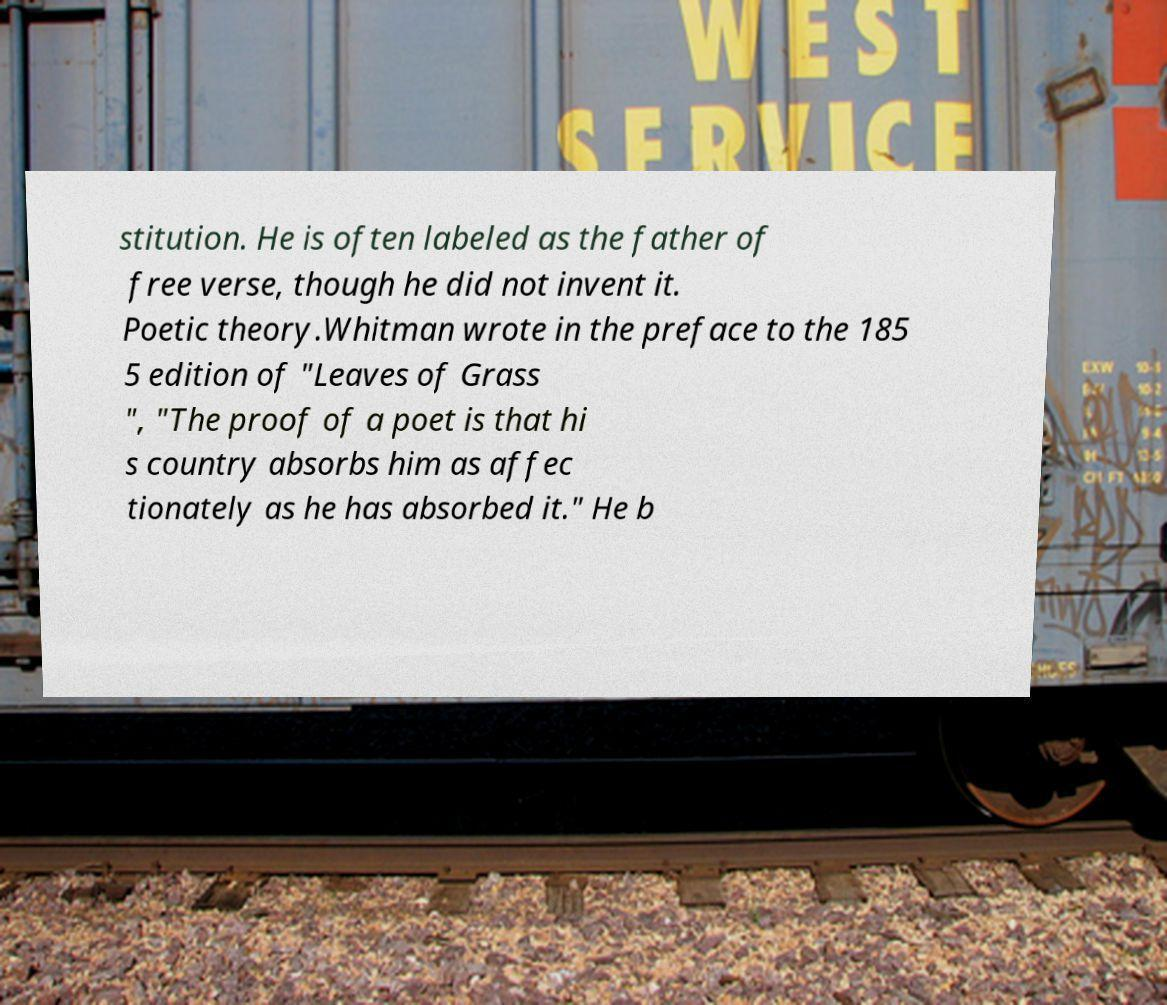I need the written content from this picture converted into text. Can you do that? stitution. He is often labeled as the father of free verse, though he did not invent it. Poetic theory.Whitman wrote in the preface to the 185 5 edition of "Leaves of Grass ", "The proof of a poet is that hi s country absorbs him as affec tionately as he has absorbed it." He b 